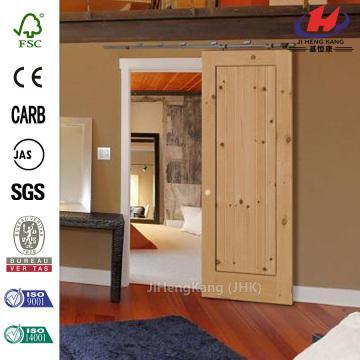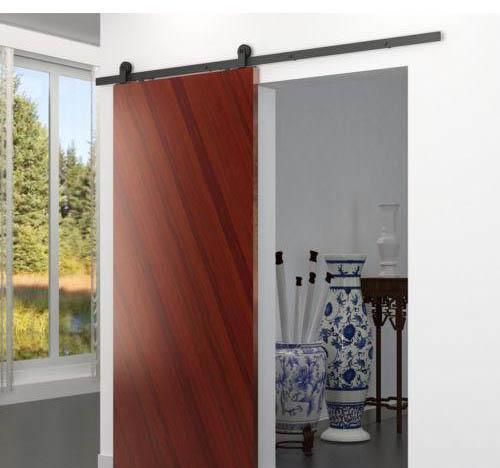The first image is the image on the left, the second image is the image on the right. For the images shown, is this caption "There are two hanging door with at least one that has whitish horizontal lines that create five triangles." true? Answer yes or no. No. The first image is the image on the left, the second image is the image on the right. Examine the images to the left and right. Is the description "In one image, the door has a horizontal strip wood grain pattern." accurate? Answer yes or no. No. 